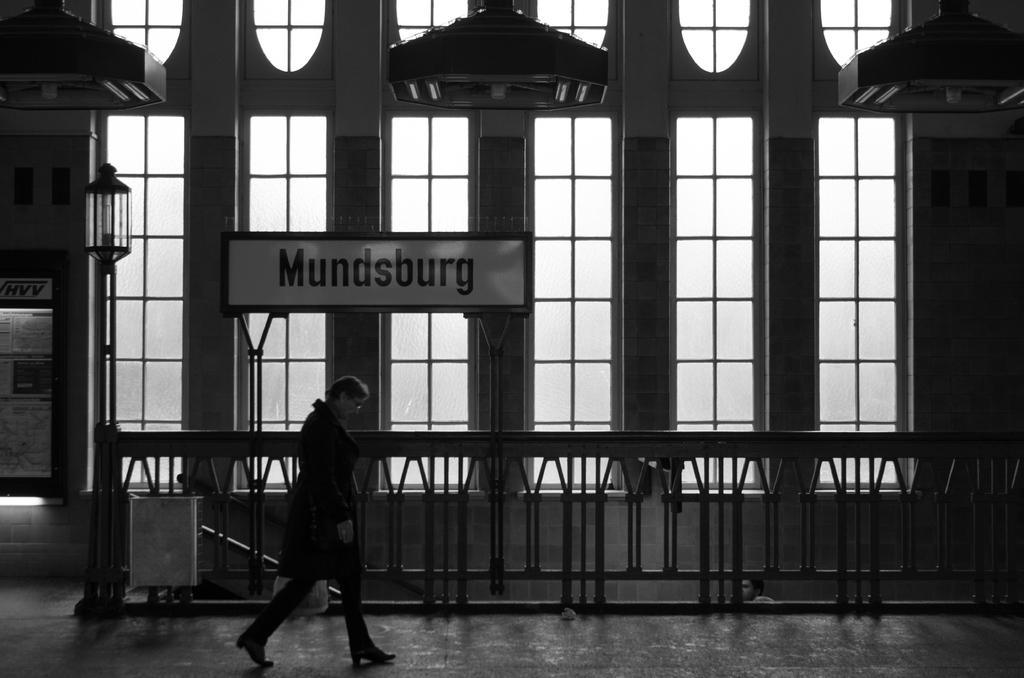Describe this image in one or two sentences. In this picture we can see couple of people, in the background we can find few metal rods, lights and a hoarding, it is a black and white photography. 